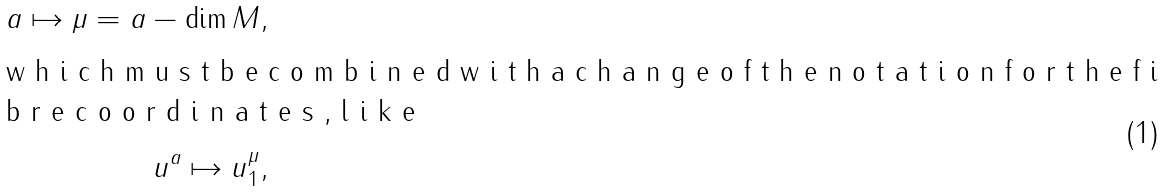Convert formula to latex. <formula><loc_0><loc_0><loc_500><loc_500>a \mapsto \mu = a - \dim M , \\ \intertext { w h i c h m u s t b e c o m b i n e d w i t h a c h a n g e o f t h e n o t a t i o n f o r t h e f i b r e c o o r d i n a t e s , l i k e } u ^ { a } \mapsto u _ { 1 } ^ { \mu } ,</formula> 